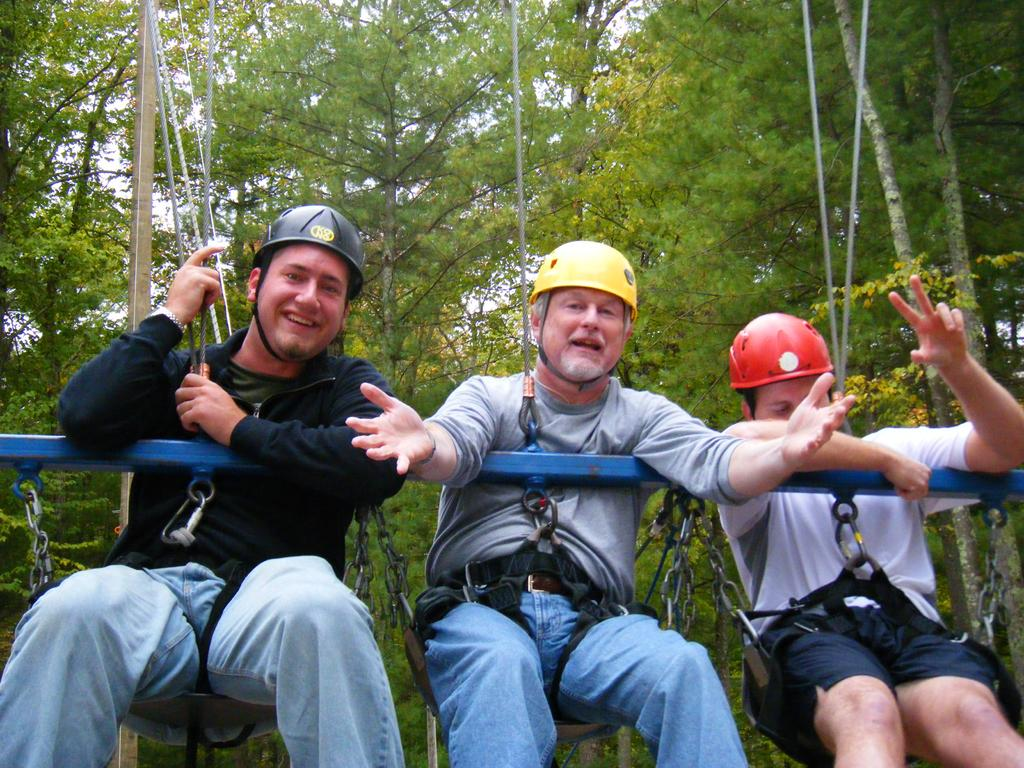How many men are in the image? There are three men in the image. What are the men doing in the image? The men are smiling and swinging in the image. What are the swings attached to in the image? The swings are attached to ropes in the image. What is in front of the men in the image? There is a metal rod in front of the men in the image. What can be seen in the background of the image? There are many trees in the background of the image. How much money is on the tray in the image? There is no tray or money present in the image. What type of ship can be seen sailing in the background of the image? There is no ship visible in the image; it features three men swinging and many trees in the background. 